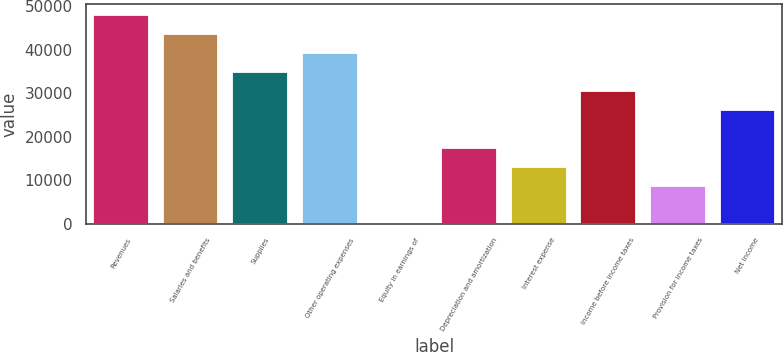Convert chart. <chart><loc_0><loc_0><loc_500><loc_500><bar_chart><fcel>Revenues<fcel>Salaries and benefits<fcel>Supplies<fcel>Other operating expenses<fcel>Equity in earnings of<fcel>Depreciation and amortization<fcel>Interest expense<fcel>Income before income taxes<fcel>Provision for income taxes<fcel>Net income<nl><fcel>47970.9<fcel>43614<fcel>34900.2<fcel>39257.1<fcel>45<fcel>17472.6<fcel>13115.7<fcel>30543.3<fcel>8758.8<fcel>26186.4<nl></chart> 